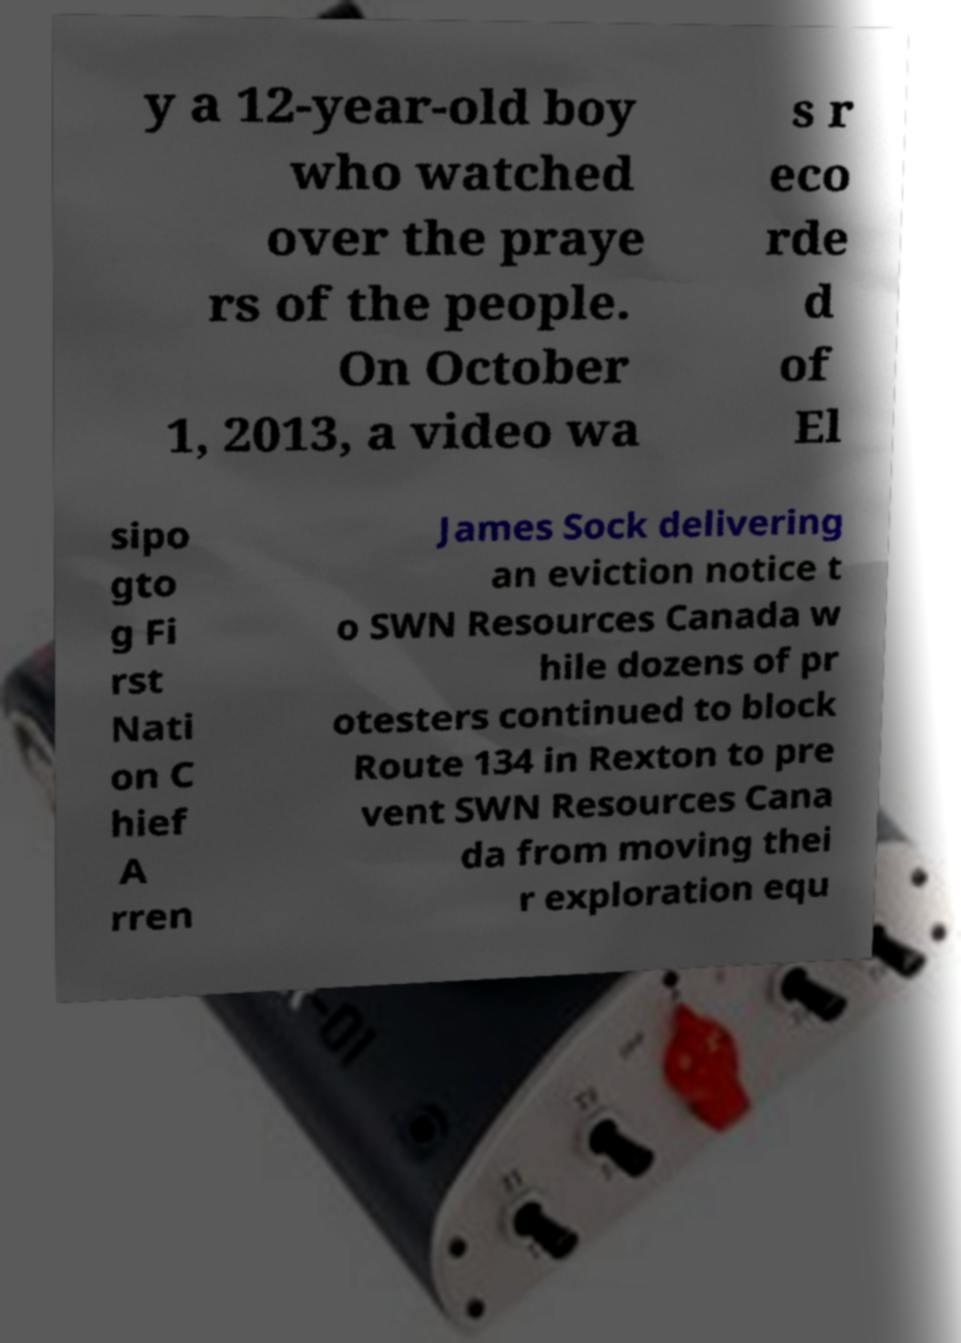Could you extract and type out the text from this image? y a 12-year-old boy who watched over the praye rs of the people. On October 1, 2013, a video wa s r eco rde d of El sipo gto g Fi rst Nati on C hief A rren James Sock delivering an eviction notice t o SWN Resources Canada w hile dozens of pr otesters continued to block Route 134 in Rexton to pre vent SWN Resources Cana da from moving thei r exploration equ 